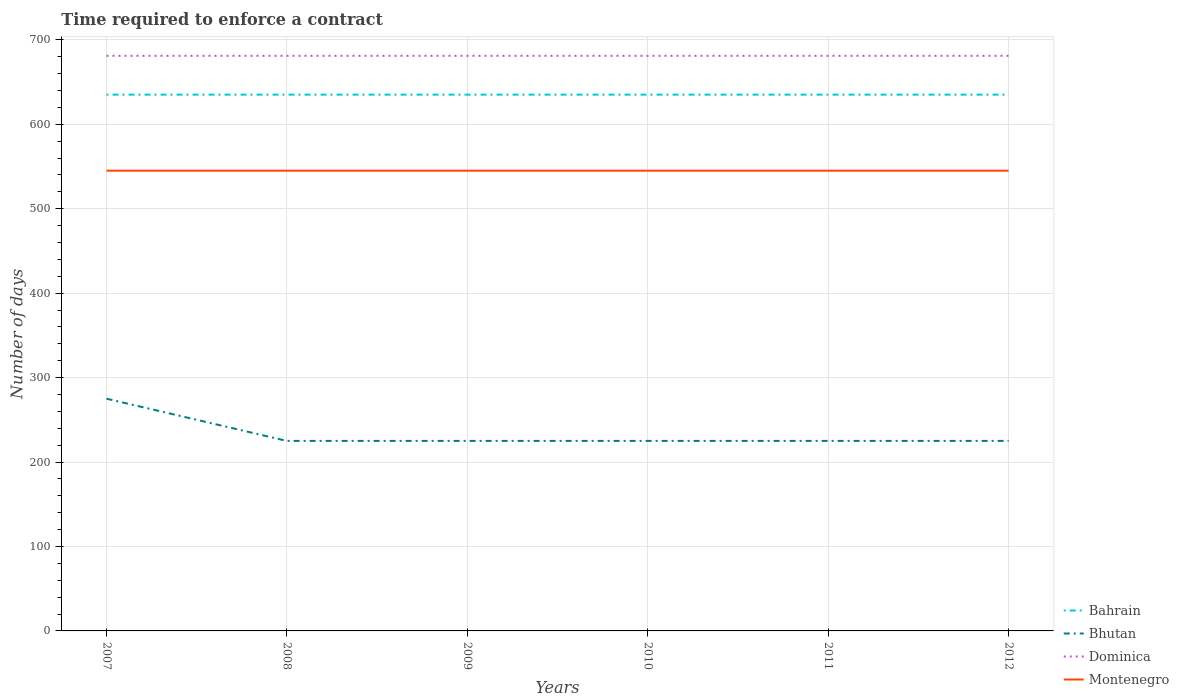How many different coloured lines are there?
Ensure brevity in your answer.  4. Across all years, what is the maximum number of days required to enforce a contract in Dominica?
Give a very brief answer. 681. In which year was the number of days required to enforce a contract in Dominica maximum?
Your response must be concise. 2007. What is the difference between the highest and the lowest number of days required to enforce a contract in Bhutan?
Your response must be concise. 1. Is the number of days required to enforce a contract in Bhutan strictly greater than the number of days required to enforce a contract in Bahrain over the years?
Make the answer very short. Yes. How many lines are there?
Make the answer very short. 4. How many years are there in the graph?
Your answer should be very brief. 6. Are the values on the major ticks of Y-axis written in scientific E-notation?
Your response must be concise. No. Does the graph contain any zero values?
Offer a terse response. No. How many legend labels are there?
Ensure brevity in your answer.  4. How are the legend labels stacked?
Your answer should be very brief. Vertical. What is the title of the graph?
Offer a terse response. Time required to enforce a contract. What is the label or title of the X-axis?
Make the answer very short. Years. What is the label or title of the Y-axis?
Provide a succinct answer. Number of days. What is the Number of days of Bahrain in 2007?
Make the answer very short. 635. What is the Number of days of Bhutan in 2007?
Your response must be concise. 275. What is the Number of days of Dominica in 2007?
Offer a terse response. 681. What is the Number of days in Montenegro in 2007?
Give a very brief answer. 545. What is the Number of days in Bahrain in 2008?
Make the answer very short. 635. What is the Number of days in Bhutan in 2008?
Offer a terse response. 225. What is the Number of days of Dominica in 2008?
Make the answer very short. 681. What is the Number of days of Montenegro in 2008?
Make the answer very short. 545. What is the Number of days in Bahrain in 2009?
Provide a succinct answer. 635. What is the Number of days in Bhutan in 2009?
Your answer should be very brief. 225. What is the Number of days in Dominica in 2009?
Your answer should be compact. 681. What is the Number of days in Montenegro in 2009?
Your answer should be compact. 545. What is the Number of days of Bahrain in 2010?
Your answer should be very brief. 635. What is the Number of days in Bhutan in 2010?
Ensure brevity in your answer.  225. What is the Number of days in Dominica in 2010?
Give a very brief answer. 681. What is the Number of days in Montenegro in 2010?
Your answer should be compact. 545. What is the Number of days of Bahrain in 2011?
Provide a short and direct response. 635. What is the Number of days in Bhutan in 2011?
Provide a short and direct response. 225. What is the Number of days in Dominica in 2011?
Give a very brief answer. 681. What is the Number of days in Montenegro in 2011?
Keep it short and to the point. 545. What is the Number of days in Bahrain in 2012?
Give a very brief answer. 635. What is the Number of days in Bhutan in 2012?
Ensure brevity in your answer.  225. What is the Number of days of Dominica in 2012?
Your answer should be very brief. 681. What is the Number of days in Montenegro in 2012?
Your answer should be very brief. 545. Across all years, what is the maximum Number of days of Bahrain?
Offer a terse response. 635. Across all years, what is the maximum Number of days of Bhutan?
Your answer should be very brief. 275. Across all years, what is the maximum Number of days of Dominica?
Your answer should be very brief. 681. Across all years, what is the maximum Number of days in Montenegro?
Provide a succinct answer. 545. Across all years, what is the minimum Number of days of Bahrain?
Keep it short and to the point. 635. Across all years, what is the minimum Number of days in Bhutan?
Provide a short and direct response. 225. Across all years, what is the minimum Number of days of Dominica?
Your answer should be compact. 681. Across all years, what is the minimum Number of days of Montenegro?
Provide a succinct answer. 545. What is the total Number of days in Bahrain in the graph?
Provide a short and direct response. 3810. What is the total Number of days in Bhutan in the graph?
Your response must be concise. 1400. What is the total Number of days of Dominica in the graph?
Make the answer very short. 4086. What is the total Number of days of Montenegro in the graph?
Your response must be concise. 3270. What is the difference between the Number of days of Bahrain in 2007 and that in 2008?
Keep it short and to the point. 0. What is the difference between the Number of days in Montenegro in 2007 and that in 2009?
Your response must be concise. 0. What is the difference between the Number of days in Montenegro in 2007 and that in 2010?
Keep it short and to the point. 0. What is the difference between the Number of days in Dominica in 2007 and that in 2011?
Offer a very short reply. 0. What is the difference between the Number of days in Bhutan in 2007 and that in 2012?
Your response must be concise. 50. What is the difference between the Number of days of Dominica in 2008 and that in 2009?
Your answer should be compact. 0. What is the difference between the Number of days of Montenegro in 2008 and that in 2009?
Provide a succinct answer. 0. What is the difference between the Number of days of Montenegro in 2008 and that in 2010?
Keep it short and to the point. 0. What is the difference between the Number of days of Dominica in 2008 and that in 2011?
Offer a terse response. 0. What is the difference between the Number of days of Bhutan in 2009 and that in 2011?
Give a very brief answer. 0. What is the difference between the Number of days of Dominica in 2009 and that in 2011?
Your response must be concise. 0. What is the difference between the Number of days in Montenegro in 2009 and that in 2011?
Make the answer very short. 0. What is the difference between the Number of days in Bhutan in 2009 and that in 2012?
Offer a terse response. 0. What is the difference between the Number of days of Dominica in 2010 and that in 2011?
Keep it short and to the point. 0. What is the difference between the Number of days of Bahrain in 2010 and that in 2012?
Your answer should be very brief. 0. What is the difference between the Number of days of Bhutan in 2010 and that in 2012?
Give a very brief answer. 0. What is the difference between the Number of days in Dominica in 2010 and that in 2012?
Your answer should be compact. 0. What is the difference between the Number of days of Bahrain in 2011 and that in 2012?
Provide a short and direct response. 0. What is the difference between the Number of days of Bhutan in 2011 and that in 2012?
Offer a very short reply. 0. What is the difference between the Number of days in Dominica in 2011 and that in 2012?
Keep it short and to the point. 0. What is the difference between the Number of days of Montenegro in 2011 and that in 2012?
Keep it short and to the point. 0. What is the difference between the Number of days of Bahrain in 2007 and the Number of days of Bhutan in 2008?
Offer a very short reply. 410. What is the difference between the Number of days of Bahrain in 2007 and the Number of days of Dominica in 2008?
Your answer should be very brief. -46. What is the difference between the Number of days of Bahrain in 2007 and the Number of days of Montenegro in 2008?
Keep it short and to the point. 90. What is the difference between the Number of days of Bhutan in 2007 and the Number of days of Dominica in 2008?
Offer a very short reply. -406. What is the difference between the Number of days of Bhutan in 2007 and the Number of days of Montenegro in 2008?
Offer a terse response. -270. What is the difference between the Number of days of Dominica in 2007 and the Number of days of Montenegro in 2008?
Your response must be concise. 136. What is the difference between the Number of days of Bahrain in 2007 and the Number of days of Bhutan in 2009?
Offer a very short reply. 410. What is the difference between the Number of days in Bahrain in 2007 and the Number of days in Dominica in 2009?
Offer a terse response. -46. What is the difference between the Number of days of Bhutan in 2007 and the Number of days of Dominica in 2009?
Give a very brief answer. -406. What is the difference between the Number of days of Bhutan in 2007 and the Number of days of Montenegro in 2009?
Ensure brevity in your answer.  -270. What is the difference between the Number of days of Dominica in 2007 and the Number of days of Montenegro in 2009?
Offer a terse response. 136. What is the difference between the Number of days of Bahrain in 2007 and the Number of days of Bhutan in 2010?
Provide a succinct answer. 410. What is the difference between the Number of days of Bahrain in 2007 and the Number of days of Dominica in 2010?
Your answer should be compact. -46. What is the difference between the Number of days in Bhutan in 2007 and the Number of days in Dominica in 2010?
Provide a short and direct response. -406. What is the difference between the Number of days in Bhutan in 2007 and the Number of days in Montenegro in 2010?
Offer a very short reply. -270. What is the difference between the Number of days in Dominica in 2007 and the Number of days in Montenegro in 2010?
Provide a short and direct response. 136. What is the difference between the Number of days of Bahrain in 2007 and the Number of days of Bhutan in 2011?
Give a very brief answer. 410. What is the difference between the Number of days in Bahrain in 2007 and the Number of days in Dominica in 2011?
Your response must be concise. -46. What is the difference between the Number of days of Bahrain in 2007 and the Number of days of Montenegro in 2011?
Make the answer very short. 90. What is the difference between the Number of days of Bhutan in 2007 and the Number of days of Dominica in 2011?
Provide a short and direct response. -406. What is the difference between the Number of days of Bhutan in 2007 and the Number of days of Montenegro in 2011?
Give a very brief answer. -270. What is the difference between the Number of days in Dominica in 2007 and the Number of days in Montenegro in 2011?
Ensure brevity in your answer.  136. What is the difference between the Number of days of Bahrain in 2007 and the Number of days of Bhutan in 2012?
Provide a short and direct response. 410. What is the difference between the Number of days in Bahrain in 2007 and the Number of days in Dominica in 2012?
Your answer should be very brief. -46. What is the difference between the Number of days of Bhutan in 2007 and the Number of days of Dominica in 2012?
Keep it short and to the point. -406. What is the difference between the Number of days of Bhutan in 2007 and the Number of days of Montenegro in 2012?
Your answer should be compact. -270. What is the difference between the Number of days of Dominica in 2007 and the Number of days of Montenegro in 2012?
Give a very brief answer. 136. What is the difference between the Number of days in Bahrain in 2008 and the Number of days in Bhutan in 2009?
Provide a short and direct response. 410. What is the difference between the Number of days of Bahrain in 2008 and the Number of days of Dominica in 2009?
Make the answer very short. -46. What is the difference between the Number of days of Bhutan in 2008 and the Number of days of Dominica in 2009?
Your response must be concise. -456. What is the difference between the Number of days of Bhutan in 2008 and the Number of days of Montenegro in 2009?
Your response must be concise. -320. What is the difference between the Number of days in Dominica in 2008 and the Number of days in Montenegro in 2009?
Your answer should be very brief. 136. What is the difference between the Number of days of Bahrain in 2008 and the Number of days of Bhutan in 2010?
Provide a short and direct response. 410. What is the difference between the Number of days of Bahrain in 2008 and the Number of days of Dominica in 2010?
Your response must be concise. -46. What is the difference between the Number of days in Bahrain in 2008 and the Number of days in Montenegro in 2010?
Ensure brevity in your answer.  90. What is the difference between the Number of days in Bhutan in 2008 and the Number of days in Dominica in 2010?
Your response must be concise. -456. What is the difference between the Number of days in Bhutan in 2008 and the Number of days in Montenegro in 2010?
Your response must be concise. -320. What is the difference between the Number of days in Dominica in 2008 and the Number of days in Montenegro in 2010?
Ensure brevity in your answer.  136. What is the difference between the Number of days in Bahrain in 2008 and the Number of days in Bhutan in 2011?
Give a very brief answer. 410. What is the difference between the Number of days of Bahrain in 2008 and the Number of days of Dominica in 2011?
Make the answer very short. -46. What is the difference between the Number of days of Bhutan in 2008 and the Number of days of Dominica in 2011?
Make the answer very short. -456. What is the difference between the Number of days of Bhutan in 2008 and the Number of days of Montenegro in 2011?
Ensure brevity in your answer.  -320. What is the difference between the Number of days in Dominica in 2008 and the Number of days in Montenegro in 2011?
Provide a succinct answer. 136. What is the difference between the Number of days in Bahrain in 2008 and the Number of days in Bhutan in 2012?
Keep it short and to the point. 410. What is the difference between the Number of days in Bahrain in 2008 and the Number of days in Dominica in 2012?
Make the answer very short. -46. What is the difference between the Number of days of Bhutan in 2008 and the Number of days of Dominica in 2012?
Your response must be concise. -456. What is the difference between the Number of days in Bhutan in 2008 and the Number of days in Montenegro in 2012?
Your answer should be very brief. -320. What is the difference between the Number of days of Dominica in 2008 and the Number of days of Montenegro in 2012?
Offer a terse response. 136. What is the difference between the Number of days in Bahrain in 2009 and the Number of days in Bhutan in 2010?
Offer a terse response. 410. What is the difference between the Number of days in Bahrain in 2009 and the Number of days in Dominica in 2010?
Your answer should be compact. -46. What is the difference between the Number of days of Bhutan in 2009 and the Number of days of Dominica in 2010?
Provide a succinct answer. -456. What is the difference between the Number of days of Bhutan in 2009 and the Number of days of Montenegro in 2010?
Your response must be concise. -320. What is the difference between the Number of days of Dominica in 2009 and the Number of days of Montenegro in 2010?
Your answer should be compact. 136. What is the difference between the Number of days of Bahrain in 2009 and the Number of days of Bhutan in 2011?
Offer a very short reply. 410. What is the difference between the Number of days in Bahrain in 2009 and the Number of days in Dominica in 2011?
Give a very brief answer. -46. What is the difference between the Number of days in Bahrain in 2009 and the Number of days in Montenegro in 2011?
Your response must be concise. 90. What is the difference between the Number of days of Bhutan in 2009 and the Number of days of Dominica in 2011?
Your answer should be very brief. -456. What is the difference between the Number of days in Bhutan in 2009 and the Number of days in Montenegro in 2011?
Ensure brevity in your answer.  -320. What is the difference between the Number of days in Dominica in 2009 and the Number of days in Montenegro in 2011?
Keep it short and to the point. 136. What is the difference between the Number of days of Bahrain in 2009 and the Number of days of Bhutan in 2012?
Provide a succinct answer. 410. What is the difference between the Number of days in Bahrain in 2009 and the Number of days in Dominica in 2012?
Your answer should be compact. -46. What is the difference between the Number of days of Bahrain in 2009 and the Number of days of Montenegro in 2012?
Your answer should be very brief. 90. What is the difference between the Number of days in Bhutan in 2009 and the Number of days in Dominica in 2012?
Ensure brevity in your answer.  -456. What is the difference between the Number of days in Bhutan in 2009 and the Number of days in Montenegro in 2012?
Your answer should be compact. -320. What is the difference between the Number of days in Dominica in 2009 and the Number of days in Montenegro in 2012?
Offer a terse response. 136. What is the difference between the Number of days in Bahrain in 2010 and the Number of days in Bhutan in 2011?
Give a very brief answer. 410. What is the difference between the Number of days of Bahrain in 2010 and the Number of days of Dominica in 2011?
Give a very brief answer. -46. What is the difference between the Number of days of Bhutan in 2010 and the Number of days of Dominica in 2011?
Your answer should be very brief. -456. What is the difference between the Number of days in Bhutan in 2010 and the Number of days in Montenegro in 2011?
Keep it short and to the point. -320. What is the difference between the Number of days of Dominica in 2010 and the Number of days of Montenegro in 2011?
Offer a terse response. 136. What is the difference between the Number of days in Bahrain in 2010 and the Number of days in Bhutan in 2012?
Your response must be concise. 410. What is the difference between the Number of days of Bahrain in 2010 and the Number of days of Dominica in 2012?
Give a very brief answer. -46. What is the difference between the Number of days of Bahrain in 2010 and the Number of days of Montenegro in 2012?
Provide a short and direct response. 90. What is the difference between the Number of days in Bhutan in 2010 and the Number of days in Dominica in 2012?
Provide a short and direct response. -456. What is the difference between the Number of days of Bhutan in 2010 and the Number of days of Montenegro in 2012?
Provide a succinct answer. -320. What is the difference between the Number of days of Dominica in 2010 and the Number of days of Montenegro in 2012?
Provide a short and direct response. 136. What is the difference between the Number of days in Bahrain in 2011 and the Number of days in Bhutan in 2012?
Ensure brevity in your answer.  410. What is the difference between the Number of days of Bahrain in 2011 and the Number of days of Dominica in 2012?
Offer a very short reply. -46. What is the difference between the Number of days of Bhutan in 2011 and the Number of days of Dominica in 2012?
Your answer should be very brief. -456. What is the difference between the Number of days of Bhutan in 2011 and the Number of days of Montenegro in 2012?
Give a very brief answer. -320. What is the difference between the Number of days of Dominica in 2011 and the Number of days of Montenegro in 2012?
Your response must be concise. 136. What is the average Number of days in Bahrain per year?
Give a very brief answer. 635. What is the average Number of days of Bhutan per year?
Keep it short and to the point. 233.33. What is the average Number of days of Dominica per year?
Offer a terse response. 681. What is the average Number of days in Montenegro per year?
Offer a very short reply. 545. In the year 2007, what is the difference between the Number of days in Bahrain and Number of days in Bhutan?
Your response must be concise. 360. In the year 2007, what is the difference between the Number of days of Bahrain and Number of days of Dominica?
Provide a short and direct response. -46. In the year 2007, what is the difference between the Number of days of Bahrain and Number of days of Montenegro?
Ensure brevity in your answer.  90. In the year 2007, what is the difference between the Number of days of Bhutan and Number of days of Dominica?
Ensure brevity in your answer.  -406. In the year 2007, what is the difference between the Number of days in Bhutan and Number of days in Montenegro?
Give a very brief answer. -270. In the year 2007, what is the difference between the Number of days of Dominica and Number of days of Montenegro?
Provide a short and direct response. 136. In the year 2008, what is the difference between the Number of days of Bahrain and Number of days of Bhutan?
Keep it short and to the point. 410. In the year 2008, what is the difference between the Number of days in Bahrain and Number of days in Dominica?
Offer a terse response. -46. In the year 2008, what is the difference between the Number of days in Bhutan and Number of days in Dominica?
Offer a very short reply. -456. In the year 2008, what is the difference between the Number of days of Bhutan and Number of days of Montenegro?
Offer a very short reply. -320. In the year 2008, what is the difference between the Number of days of Dominica and Number of days of Montenegro?
Your response must be concise. 136. In the year 2009, what is the difference between the Number of days of Bahrain and Number of days of Bhutan?
Give a very brief answer. 410. In the year 2009, what is the difference between the Number of days in Bahrain and Number of days in Dominica?
Your answer should be very brief. -46. In the year 2009, what is the difference between the Number of days in Bahrain and Number of days in Montenegro?
Ensure brevity in your answer.  90. In the year 2009, what is the difference between the Number of days in Bhutan and Number of days in Dominica?
Offer a terse response. -456. In the year 2009, what is the difference between the Number of days of Bhutan and Number of days of Montenegro?
Provide a succinct answer. -320. In the year 2009, what is the difference between the Number of days in Dominica and Number of days in Montenegro?
Make the answer very short. 136. In the year 2010, what is the difference between the Number of days of Bahrain and Number of days of Bhutan?
Ensure brevity in your answer.  410. In the year 2010, what is the difference between the Number of days in Bahrain and Number of days in Dominica?
Give a very brief answer. -46. In the year 2010, what is the difference between the Number of days of Bahrain and Number of days of Montenegro?
Offer a terse response. 90. In the year 2010, what is the difference between the Number of days in Bhutan and Number of days in Dominica?
Offer a terse response. -456. In the year 2010, what is the difference between the Number of days in Bhutan and Number of days in Montenegro?
Give a very brief answer. -320. In the year 2010, what is the difference between the Number of days of Dominica and Number of days of Montenegro?
Your answer should be very brief. 136. In the year 2011, what is the difference between the Number of days of Bahrain and Number of days of Bhutan?
Your response must be concise. 410. In the year 2011, what is the difference between the Number of days of Bahrain and Number of days of Dominica?
Give a very brief answer. -46. In the year 2011, what is the difference between the Number of days in Bahrain and Number of days in Montenegro?
Offer a very short reply. 90. In the year 2011, what is the difference between the Number of days in Bhutan and Number of days in Dominica?
Give a very brief answer. -456. In the year 2011, what is the difference between the Number of days of Bhutan and Number of days of Montenegro?
Your answer should be compact. -320. In the year 2011, what is the difference between the Number of days in Dominica and Number of days in Montenegro?
Keep it short and to the point. 136. In the year 2012, what is the difference between the Number of days of Bahrain and Number of days of Bhutan?
Ensure brevity in your answer.  410. In the year 2012, what is the difference between the Number of days in Bahrain and Number of days in Dominica?
Your answer should be very brief. -46. In the year 2012, what is the difference between the Number of days in Bhutan and Number of days in Dominica?
Give a very brief answer. -456. In the year 2012, what is the difference between the Number of days in Bhutan and Number of days in Montenegro?
Make the answer very short. -320. In the year 2012, what is the difference between the Number of days in Dominica and Number of days in Montenegro?
Offer a terse response. 136. What is the ratio of the Number of days in Bahrain in 2007 to that in 2008?
Keep it short and to the point. 1. What is the ratio of the Number of days of Bhutan in 2007 to that in 2008?
Offer a very short reply. 1.22. What is the ratio of the Number of days in Dominica in 2007 to that in 2008?
Provide a succinct answer. 1. What is the ratio of the Number of days of Montenegro in 2007 to that in 2008?
Your answer should be compact. 1. What is the ratio of the Number of days in Bahrain in 2007 to that in 2009?
Give a very brief answer. 1. What is the ratio of the Number of days in Bhutan in 2007 to that in 2009?
Give a very brief answer. 1.22. What is the ratio of the Number of days of Dominica in 2007 to that in 2009?
Provide a succinct answer. 1. What is the ratio of the Number of days in Bahrain in 2007 to that in 2010?
Keep it short and to the point. 1. What is the ratio of the Number of days in Bhutan in 2007 to that in 2010?
Give a very brief answer. 1.22. What is the ratio of the Number of days in Bhutan in 2007 to that in 2011?
Provide a short and direct response. 1.22. What is the ratio of the Number of days in Dominica in 2007 to that in 2011?
Give a very brief answer. 1. What is the ratio of the Number of days of Bahrain in 2007 to that in 2012?
Your answer should be very brief. 1. What is the ratio of the Number of days of Bhutan in 2007 to that in 2012?
Offer a very short reply. 1.22. What is the ratio of the Number of days in Montenegro in 2007 to that in 2012?
Make the answer very short. 1. What is the ratio of the Number of days of Montenegro in 2008 to that in 2009?
Offer a very short reply. 1. What is the ratio of the Number of days in Bahrain in 2008 to that in 2010?
Offer a terse response. 1. What is the ratio of the Number of days of Bhutan in 2008 to that in 2010?
Ensure brevity in your answer.  1. What is the ratio of the Number of days in Dominica in 2008 to that in 2010?
Ensure brevity in your answer.  1. What is the ratio of the Number of days of Montenegro in 2008 to that in 2010?
Your response must be concise. 1. What is the ratio of the Number of days in Bahrain in 2008 to that in 2011?
Your response must be concise. 1. What is the ratio of the Number of days in Bhutan in 2008 to that in 2011?
Provide a succinct answer. 1. What is the ratio of the Number of days in Montenegro in 2008 to that in 2011?
Offer a terse response. 1. What is the ratio of the Number of days of Bahrain in 2008 to that in 2012?
Provide a short and direct response. 1. What is the ratio of the Number of days in Bhutan in 2008 to that in 2012?
Keep it short and to the point. 1. What is the ratio of the Number of days of Dominica in 2008 to that in 2012?
Provide a short and direct response. 1. What is the ratio of the Number of days of Montenegro in 2008 to that in 2012?
Offer a very short reply. 1. What is the ratio of the Number of days in Bahrain in 2009 to that in 2010?
Make the answer very short. 1. What is the ratio of the Number of days in Bhutan in 2009 to that in 2010?
Provide a short and direct response. 1. What is the ratio of the Number of days in Dominica in 2009 to that in 2010?
Offer a terse response. 1. What is the ratio of the Number of days in Bahrain in 2009 to that in 2011?
Your answer should be very brief. 1. What is the ratio of the Number of days in Montenegro in 2009 to that in 2011?
Offer a terse response. 1. What is the ratio of the Number of days in Dominica in 2009 to that in 2012?
Provide a short and direct response. 1. What is the ratio of the Number of days in Bahrain in 2010 to that in 2011?
Make the answer very short. 1. What is the ratio of the Number of days in Dominica in 2010 to that in 2011?
Your answer should be compact. 1. What is the ratio of the Number of days in Bahrain in 2010 to that in 2012?
Ensure brevity in your answer.  1. What is the ratio of the Number of days in Dominica in 2010 to that in 2012?
Your answer should be very brief. 1. What is the ratio of the Number of days of Bahrain in 2011 to that in 2012?
Offer a terse response. 1. What is the ratio of the Number of days of Bhutan in 2011 to that in 2012?
Ensure brevity in your answer.  1. What is the difference between the highest and the lowest Number of days of Bhutan?
Give a very brief answer. 50. What is the difference between the highest and the lowest Number of days in Montenegro?
Provide a short and direct response. 0. 